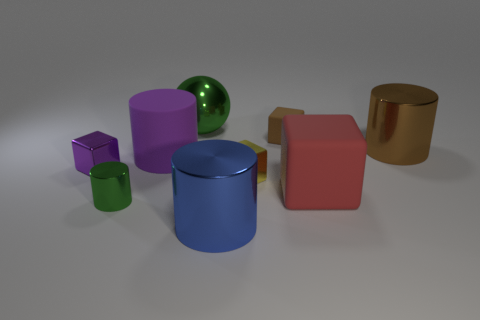Is the size of the yellow cube the same as the green metallic thing behind the large brown thing?
Offer a very short reply. No. What is the color of the large thing that is both in front of the yellow block and left of the tiny matte object?
Make the answer very short. Blue. There is a green shiny sphere that is left of the small brown block; is there a cylinder that is right of it?
Make the answer very short. Yes. Is the number of small brown matte blocks that are behind the small matte object the same as the number of cyan metallic balls?
Give a very brief answer. Yes. What number of shiny objects are behind the cylinder that is to the right of the matte cube that is in front of the small brown block?
Your response must be concise. 1. Are there any cyan shiny things of the same size as the blue metal cylinder?
Provide a short and direct response. No. Are there fewer big red rubber objects in front of the small rubber block than large brown shiny objects?
Your response must be concise. No. There is a green object that is behind the shiny cube behind the tiny metallic thing that is to the right of the large green metallic ball; what is its material?
Make the answer very short. Metal. Are there more big green balls that are in front of the big purple cylinder than small green metallic objects that are to the right of the blue thing?
Make the answer very short. No. What number of metallic objects are either gray spheres or small brown cubes?
Your answer should be very brief. 0. 